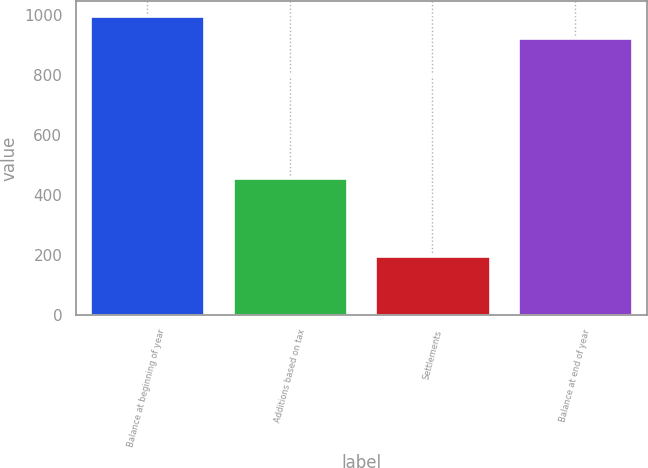Convert chart. <chart><loc_0><loc_0><loc_500><loc_500><bar_chart><fcel>Balance at beginning of year<fcel>Additions based on tax<fcel>Settlements<fcel>Balance at end of year<nl><fcel>996.8<fcel>458<fcel>197<fcel>922<nl></chart> 